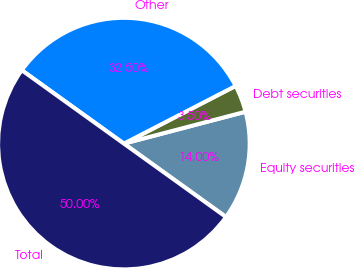Convert chart. <chart><loc_0><loc_0><loc_500><loc_500><pie_chart><fcel>Equity securities<fcel>Debt securities<fcel>Other<fcel>Total<nl><fcel>14.0%<fcel>3.5%<fcel>32.5%<fcel>50.0%<nl></chart> 